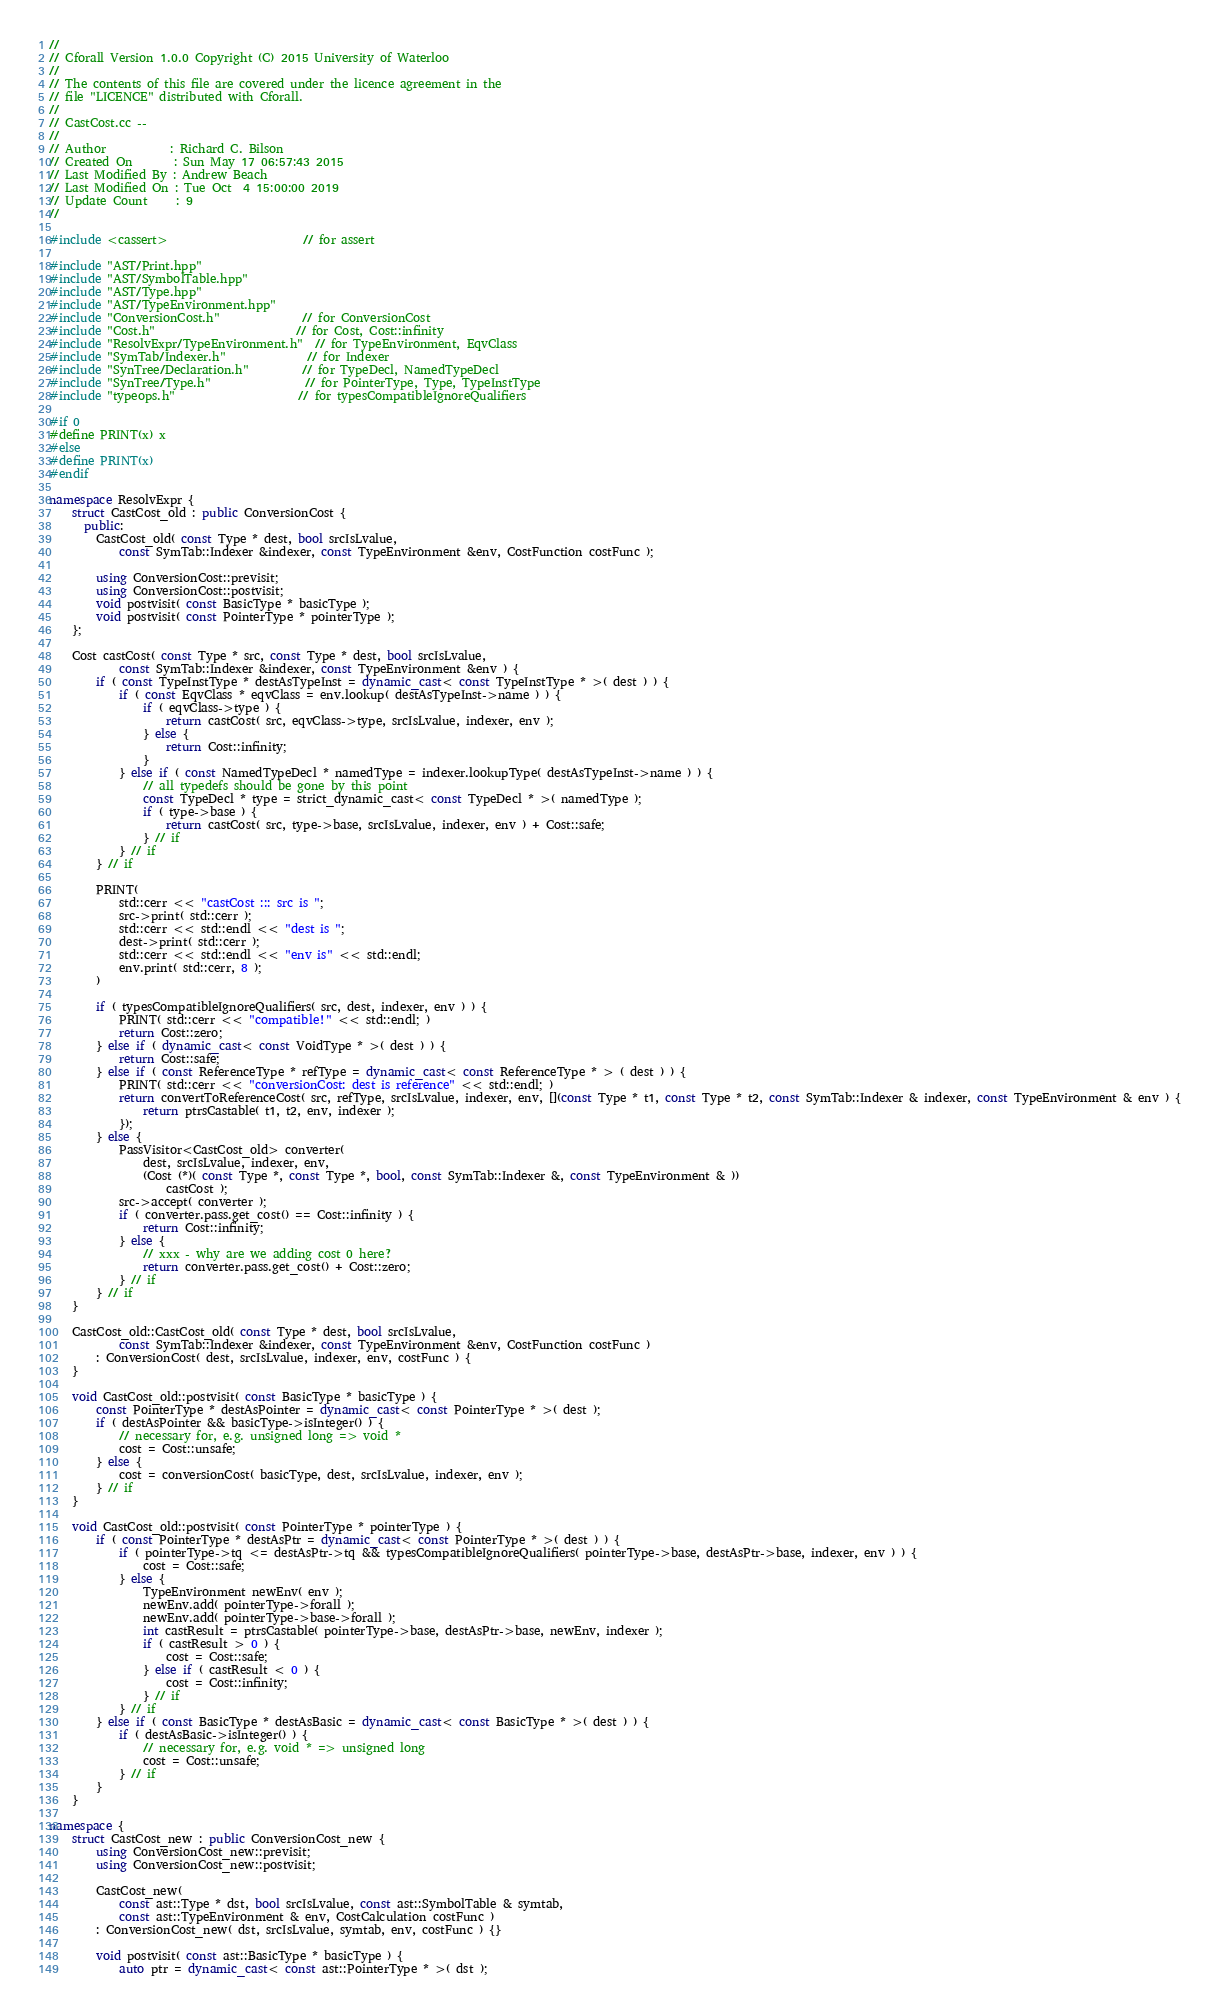Convert code to text. <code><loc_0><loc_0><loc_500><loc_500><_C++_>//
// Cforall Version 1.0.0 Copyright (C) 2015 University of Waterloo
//
// The contents of this file are covered under the licence agreement in the
// file "LICENCE" distributed with Cforall.
//
// CastCost.cc --
//
// Author           : Richard C. Bilson
// Created On       : Sun May 17 06:57:43 2015
// Last Modified By : Andrew Beach
// Last Modified On : Tue Oct  4 15:00:00 2019
// Update Count     : 9
//

#include <cassert>                       // for assert

#include "AST/Print.hpp"
#include "AST/SymbolTable.hpp"
#include "AST/Type.hpp"
#include "AST/TypeEnvironment.hpp"
#include "ConversionCost.h"              // for ConversionCost
#include "Cost.h"                        // for Cost, Cost::infinity
#include "ResolvExpr/TypeEnvironment.h"  // for TypeEnvironment, EqvClass
#include "SymTab/Indexer.h"              // for Indexer
#include "SynTree/Declaration.h"         // for TypeDecl, NamedTypeDecl
#include "SynTree/Type.h"                // for PointerType, Type, TypeInstType
#include "typeops.h"                     // for typesCompatibleIgnoreQualifiers

#if 0
#define PRINT(x) x
#else
#define PRINT(x)
#endif

namespace ResolvExpr {
	struct CastCost_old : public ConversionCost {
	  public:
		CastCost_old( const Type * dest, bool srcIsLvalue,
			const SymTab::Indexer &indexer, const TypeEnvironment &env, CostFunction costFunc );

		using ConversionCost::previsit;
		using ConversionCost::postvisit;
		void postvisit( const BasicType * basicType );
		void postvisit( const PointerType * pointerType );
	};

	Cost castCost( const Type * src, const Type * dest, bool srcIsLvalue,
			const SymTab::Indexer &indexer, const TypeEnvironment &env ) {
		if ( const TypeInstType * destAsTypeInst = dynamic_cast< const TypeInstType * >( dest ) ) {
			if ( const EqvClass * eqvClass = env.lookup( destAsTypeInst->name ) ) {
				if ( eqvClass->type ) {
					return castCost( src, eqvClass->type, srcIsLvalue, indexer, env );
				} else {
					return Cost::infinity;
				}
			} else if ( const NamedTypeDecl * namedType = indexer.lookupType( destAsTypeInst->name ) ) {
				// all typedefs should be gone by this point
				const TypeDecl * type = strict_dynamic_cast< const TypeDecl * >( namedType );
				if ( type->base ) {
					return castCost( src, type->base, srcIsLvalue, indexer, env ) + Cost::safe;
				} // if
			} // if
		} // if

		PRINT(
			std::cerr << "castCost ::: src is ";
			src->print( std::cerr );
			std::cerr << std::endl << "dest is ";
			dest->print( std::cerr );
			std::cerr << std::endl << "env is" << std::endl;
			env.print( std::cerr, 8 );
		)

		if ( typesCompatibleIgnoreQualifiers( src, dest, indexer, env ) ) {
			PRINT( std::cerr << "compatible!" << std::endl; )
			return Cost::zero;
		} else if ( dynamic_cast< const VoidType * >( dest ) ) {
			return Cost::safe;
		} else if ( const ReferenceType * refType = dynamic_cast< const ReferenceType * > ( dest ) ) {
			PRINT( std::cerr << "conversionCost: dest is reference" << std::endl; )
			return convertToReferenceCost( src, refType, srcIsLvalue, indexer, env, [](const Type * t1, const Type * t2, const SymTab::Indexer & indexer, const TypeEnvironment & env ) {
				return ptrsCastable( t1, t2, env, indexer );
			});
		} else {
			PassVisitor<CastCost_old> converter(
				dest, srcIsLvalue, indexer, env,
				(Cost (*)( const Type *, const Type *, bool, const SymTab::Indexer &, const TypeEnvironment & ))
					castCost );
			src->accept( converter );
			if ( converter.pass.get_cost() == Cost::infinity ) {
				return Cost::infinity;
			} else {
				// xxx - why are we adding cost 0 here?
				return converter.pass.get_cost() + Cost::zero;
			} // if
		} // if
	}

	CastCost_old::CastCost_old( const Type * dest, bool srcIsLvalue,
			const SymTab::Indexer &indexer, const TypeEnvironment &env, CostFunction costFunc )
		: ConversionCost( dest, srcIsLvalue, indexer, env, costFunc ) {
	}

	void CastCost_old::postvisit( const BasicType * basicType ) {
		const PointerType * destAsPointer = dynamic_cast< const PointerType * >( dest );
		if ( destAsPointer && basicType->isInteger() ) {
			// necessary for, e.g. unsigned long => void *
			cost = Cost::unsafe;
		} else {
			cost = conversionCost( basicType, dest, srcIsLvalue, indexer, env );
		} // if
	}

	void CastCost_old::postvisit( const PointerType * pointerType ) {
		if ( const PointerType * destAsPtr = dynamic_cast< const PointerType * >( dest ) ) {
			if ( pointerType->tq <= destAsPtr->tq && typesCompatibleIgnoreQualifiers( pointerType->base, destAsPtr->base, indexer, env ) ) {
				cost = Cost::safe;
			} else {
				TypeEnvironment newEnv( env );
				newEnv.add( pointerType->forall );
				newEnv.add( pointerType->base->forall );
				int castResult = ptrsCastable( pointerType->base, destAsPtr->base, newEnv, indexer );
				if ( castResult > 0 ) {
					cost = Cost::safe;
				} else if ( castResult < 0 ) {
					cost = Cost::infinity;
				} // if
			} // if
		} else if ( const BasicType * destAsBasic = dynamic_cast< const BasicType * >( dest ) ) {
			if ( destAsBasic->isInteger() ) {
				// necessary for, e.g. void * => unsigned long
				cost = Cost::unsafe;
			} // if
		}
	}

namespace {
	struct CastCost_new : public ConversionCost_new {
		using ConversionCost_new::previsit;
		using ConversionCost_new::postvisit;

		CastCost_new(
			const ast::Type * dst, bool srcIsLvalue, const ast::SymbolTable & symtab,
			const ast::TypeEnvironment & env, CostCalculation costFunc )
		: ConversionCost_new( dst, srcIsLvalue, symtab, env, costFunc ) {}

		void postvisit( const ast::BasicType * basicType ) {
			auto ptr = dynamic_cast< const ast::PointerType * >( dst );</code> 